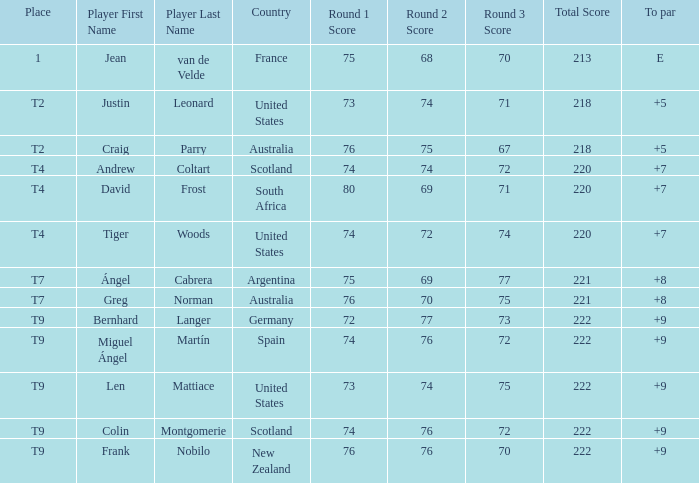What is the To Par score for the player from South Africa? 7.0. 